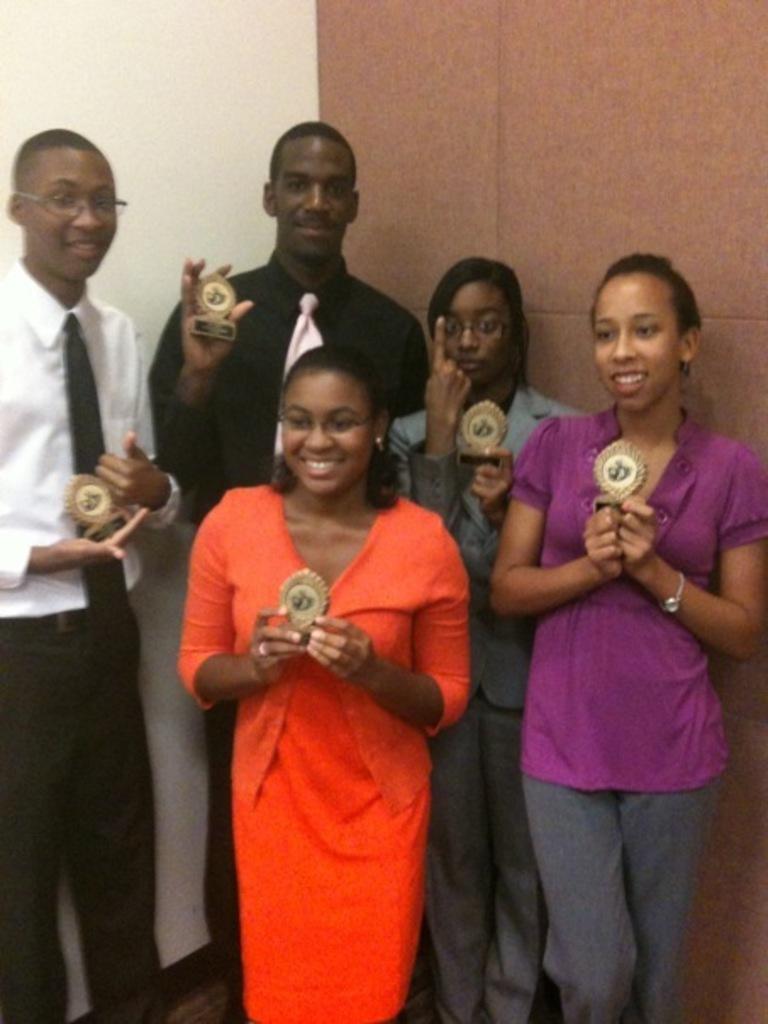Describe this image in one or two sentences. In the image there are a group of people standing and they are holding some awards with their hands, in the background there is a wall. 